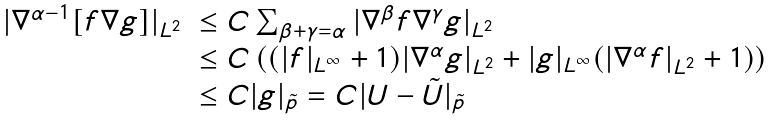<formula> <loc_0><loc_0><loc_500><loc_500>\begin{array} { r l } | \nabla ^ { \alpha - 1 } [ f \nabla g ] | _ { L ^ { 2 } } & \leq C \sum _ { \beta + \gamma = \alpha } | \nabla ^ { \beta } f \nabla ^ { \gamma } g | _ { L ^ { 2 } } \\ & \leq C \left ( ( | f | _ { L ^ { \infty } } + 1 ) | \nabla ^ { \alpha } g | _ { L ^ { 2 } } + | g | _ { L ^ { \infty } } ( | \nabla ^ { \alpha } f | _ { L ^ { 2 } } + 1 ) \right ) \\ & \leq C | g | _ { \tilde { p } } = C | U - \tilde { U } | _ { \tilde { p } } \end{array}</formula> 